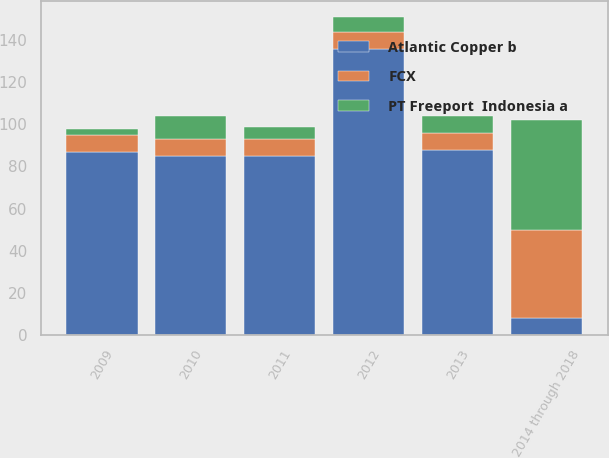<chart> <loc_0><loc_0><loc_500><loc_500><stacked_bar_chart><ecel><fcel>2009<fcel>2010<fcel>2011<fcel>2012<fcel>2013<fcel>2014 through 2018<nl><fcel>Atlantic Copper b<fcel>87<fcel>85<fcel>85<fcel>136<fcel>88<fcel>8<nl><fcel>PT Freeport  Indonesia a<fcel>3<fcel>11<fcel>6<fcel>7<fcel>8<fcel>52<nl><fcel>FCX<fcel>8<fcel>8<fcel>8<fcel>8<fcel>8<fcel>42<nl></chart> 